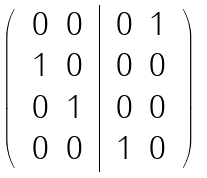Convert formula to latex. <formula><loc_0><loc_0><loc_500><loc_500>\left ( \begin{array} { c | c } \begin{array} { c c } 0 & 0 \\ 1 & 0 \end{array} & \begin{array} { c c } 0 & 1 \\ 0 & 0 \end{array} \\ \begin{array} { c c } 0 & 1 \\ 0 & 0 \end{array} & \begin{array} { c c } 0 & 0 \\ 1 & 0 \end{array} \end{array} \right )</formula> 